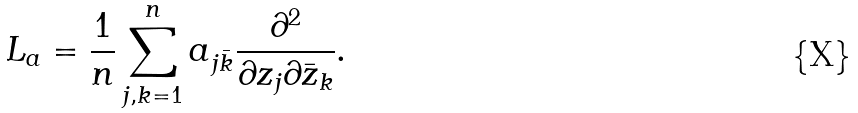Convert formula to latex. <formula><loc_0><loc_0><loc_500><loc_500>L _ { a } = \frac { 1 } { n } \sum _ { j , k = 1 } ^ { n } a _ { j \bar { k } } \frac { \partial ^ { 2 } } { \partial z _ { j } \partial \bar { z } _ { k } } .</formula> 